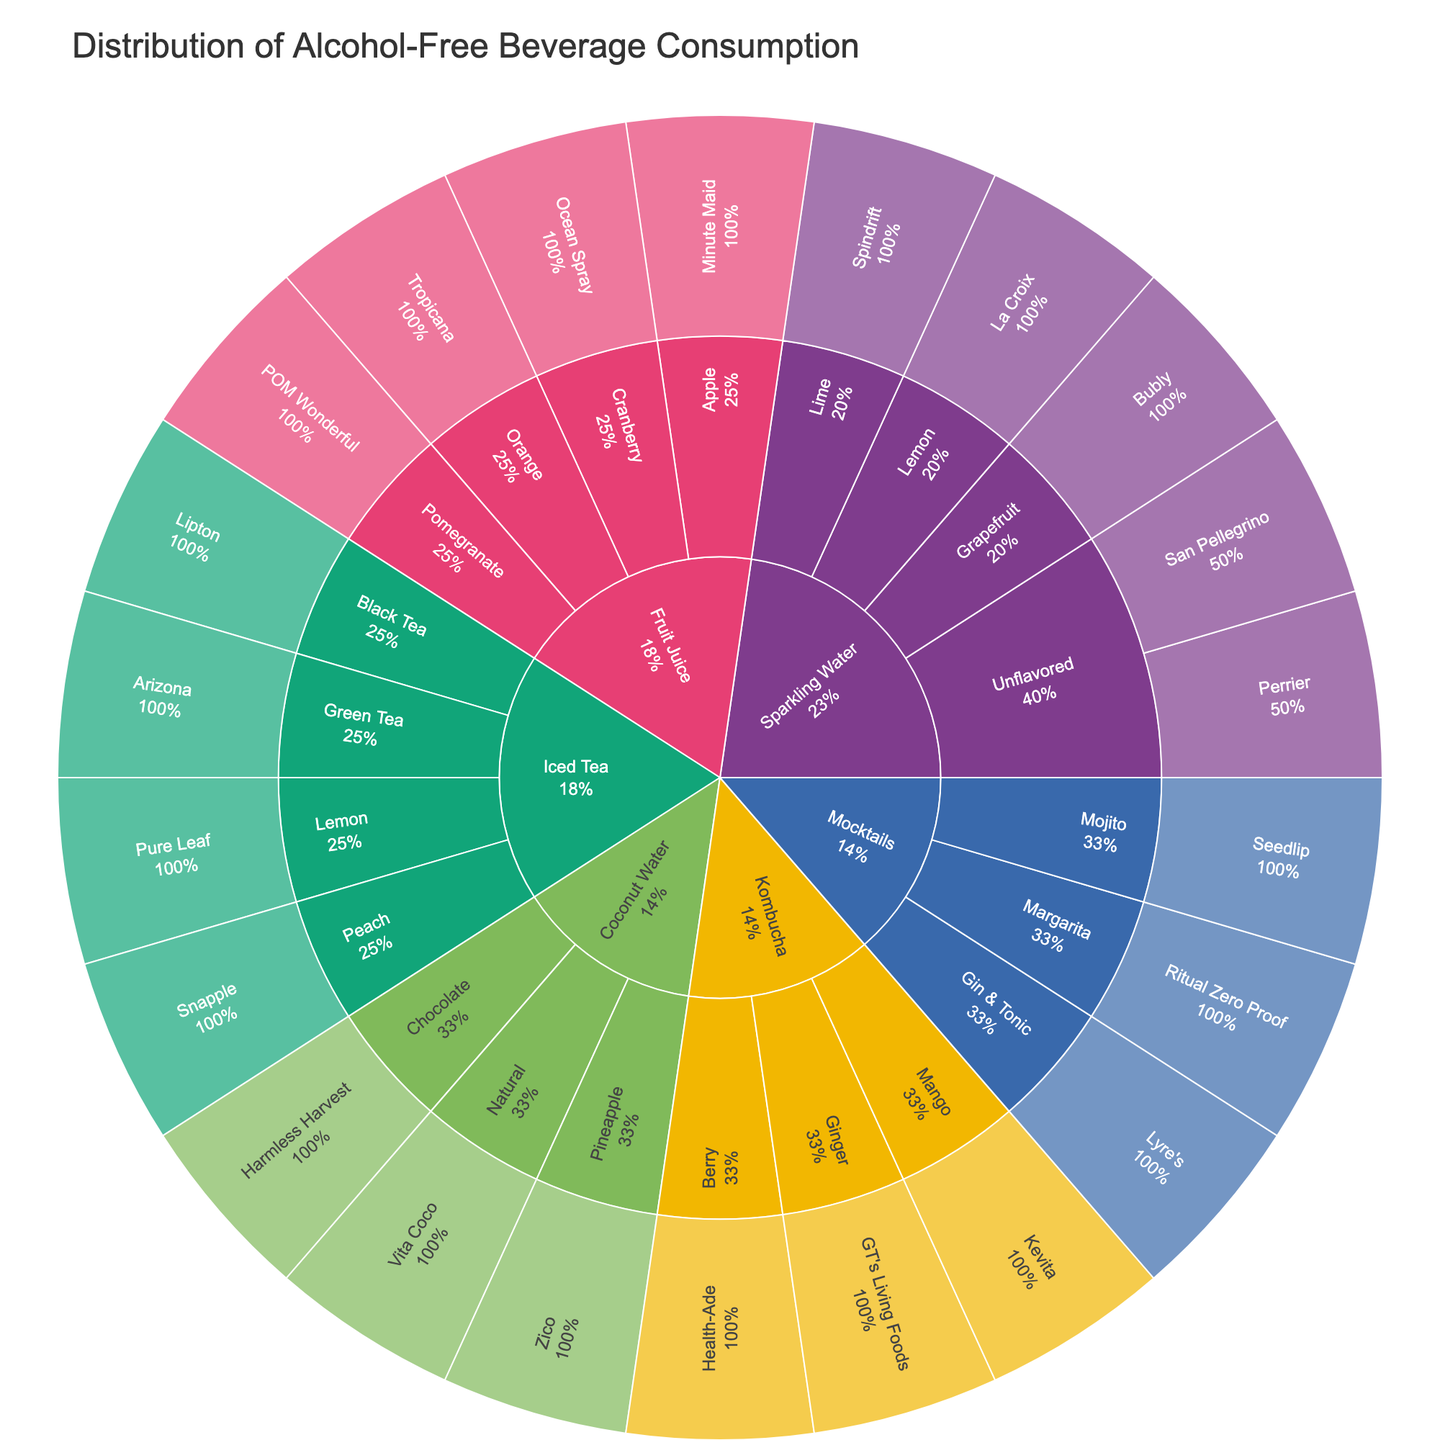What is the title of the sunburst plot? The title of the figure is usually located at the top and describes what the plot is about.
Answer: Distribution of Alcohol-Free Beverage Consumption Which type has the most variety of flavors? To find the type with the most variety of flavors, count the number of different flavors listed under each type.
Answer: Sparkling Water How many brands of iced tea are shown in the plot? Look at the Iced Tea section of the Sunburst plot and count the number of unique brands.
Answer: 4 In the Sparkling Water category, what percentage of the total does the Lemon flavor represent? Find the Lemon flavor in the Sparkling Water section and read the percentage indicated.
Answer: The Lemon flavor's percentage relative to Sparkling Water is shown directly in the Sunburst plot Compare the number of brands between Mocktails and Kombucha. Which type has more brands? Look at the number of brands listed under Mocktails and Kombucha.
Answer: Kombucha Which flavor of Fruit Juice is represented by the brand POM Wonderful? Locate the Fruit Juice section, find POM Wonderful, and see which flavor it is associated with.
Answer: Pomegranate Is the percentage of Coconut Water flavors higher or lower than Kombucha flavors? Compare the displayed percentages of Coconut Water and Kombucha at the first level of the Sunburst plot.
Answer: This can be compared directly by reading the percentages from the plot What is the most common brand in the fruit juice category? Check the Fruit Juice section for the brand that appears most often.
Answer: Each brand appears once, so there is no most common brand Which has more brands: Sparkling Water with Lime flavor or Mocktails with Mojito flavor? Find the Sparkling Water Lime flavor and the Mocktails Mojito flavor sections and count the brands under each.
Answer: Sparkling Water with Lime flavor has more brands 